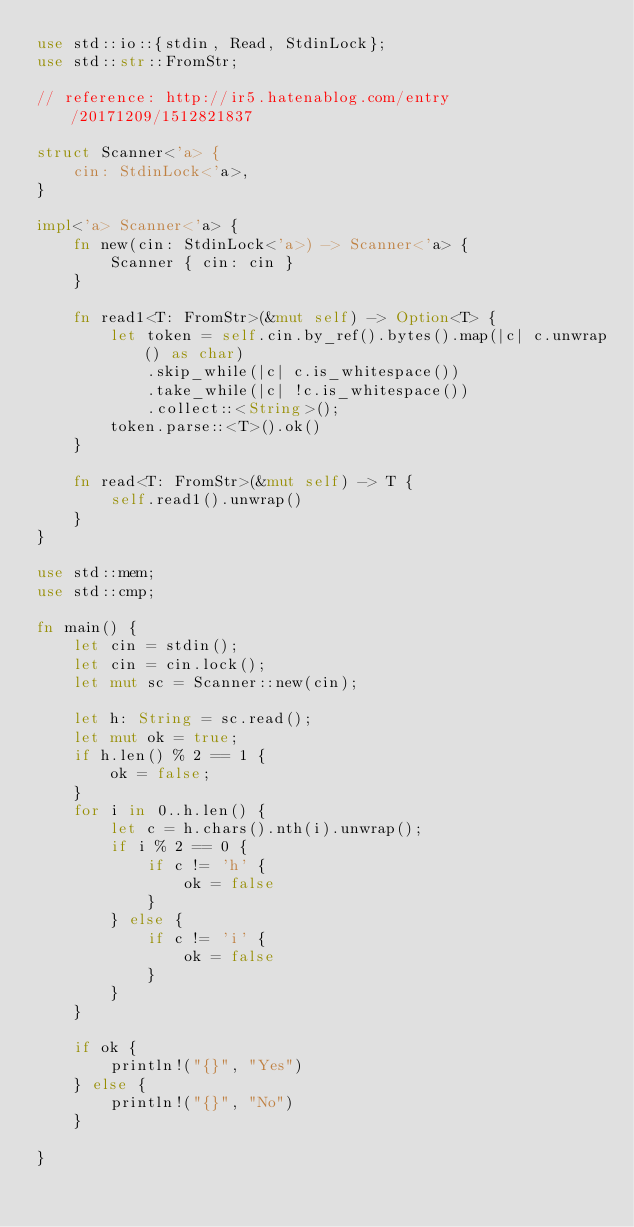Convert code to text. <code><loc_0><loc_0><loc_500><loc_500><_Rust_>use std::io::{stdin, Read, StdinLock};
use std::str::FromStr;

// reference: http://ir5.hatenablog.com/entry/20171209/1512821837

struct Scanner<'a> {
    cin: StdinLock<'a>,
}
 
impl<'a> Scanner<'a> {
    fn new(cin: StdinLock<'a>) -> Scanner<'a> {
        Scanner { cin: cin }
    }
 
    fn read1<T: FromStr>(&mut self) -> Option<T> {
        let token = self.cin.by_ref().bytes().map(|c| c.unwrap() as char)
            .skip_while(|c| c.is_whitespace())
            .take_while(|c| !c.is_whitespace())
            .collect::<String>();
        token.parse::<T>().ok()
    }
 
    fn read<T: FromStr>(&mut self) -> T {
        self.read1().unwrap()
    }
}

use std::mem;
use std::cmp;

fn main() {
    let cin = stdin();
    let cin = cin.lock();
    let mut sc = Scanner::new(cin);

    let h: String = sc.read();
    let mut ok = true;
    if h.len() % 2 == 1 {
        ok = false;
    }
    for i in 0..h.len() {
        let c = h.chars().nth(i).unwrap();
        if i % 2 == 0 {
            if c != 'h' {
                ok = false
            }
        } else {
            if c != 'i' {
                ok = false
            }
        }
    }

    if ok {
        println!("{}", "Yes")
    } else {
        println!("{}", "No")
    }

}</code> 